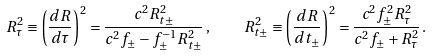Convert formula to latex. <formula><loc_0><loc_0><loc_500><loc_500>R _ { \tau } ^ { 2 } \equiv \left ( \frac { d R } { d \tau } \right ) ^ { 2 } = \frac { c ^ { 2 } R ^ { 2 } _ { t \pm } } { c ^ { 2 } f _ { \pm } - f ^ { - 1 } _ { \pm } R ^ { 2 } _ { t \pm } } \, , \quad R _ { t \pm } ^ { 2 } \equiv \left ( \frac { d R } { d t _ { \pm } } \right ) ^ { 2 } = \frac { c ^ { 2 } f ^ { 2 } _ { \pm } R ^ { 2 } _ { \tau } } { c ^ { 2 } f _ { \pm } + R ^ { 2 } _ { \tau } } \, .</formula> 